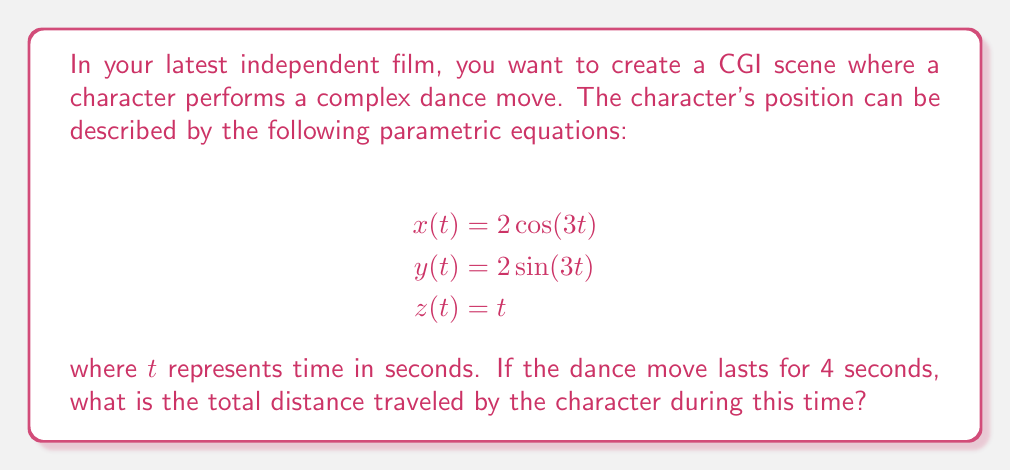Show me your answer to this math problem. To solve this problem, we need to follow these steps:

1) The distance traveled is the length of the curve described by the parametric equations. We can calculate this using the arc length formula for parametric equations:

   $$L = \int_a^b \sqrt{\left(\frac{dx}{dt}\right)^2 + \left(\frac{dy}{dt}\right)^2 + \left(\frac{dz}{dt}\right)^2} dt$$

2) First, let's find the derivatives:
   $$\frac{dx}{dt} = -6\sin(3t)$$
   $$\frac{dy}{dt} = 6\cos(3t)$$
   $$\frac{dz}{dt} = 1$$

3) Now, let's substitute these into the arc length formula:

   $$L = \int_0^4 \sqrt{(-6\sin(3t))^2 + (6\cos(3t))^2 + 1^2} dt$$

4) Simplify under the square root:
   $$L = \int_0^4 \sqrt{36\sin^2(3t) + 36\cos^2(3t) + 1} dt$$

5) Recall the trigonometric identity $\sin^2(x) + \cos^2(x) = 1$:
   $$L = \int_0^4 \sqrt{36(\sin^2(3t) + \cos^2(3t)) + 1} dt = \int_0^4 \sqrt{36 + 1} dt = \int_0^4 \sqrt{37} dt$$

6) Now we can easily integrate:
   $$L = \sqrt{37} \int_0^4 dt = \sqrt{37} [t]_0^4 = 4\sqrt{37}$$

Thus, the total distance traveled is $4\sqrt{37}$ units.
Answer: $4\sqrt{37}$ units 